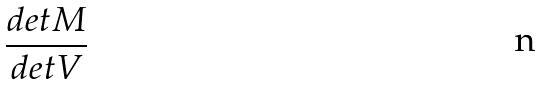Convert formula to latex. <formula><loc_0><loc_0><loc_500><loc_500>\frac { d e t M } { d e t V }</formula> 